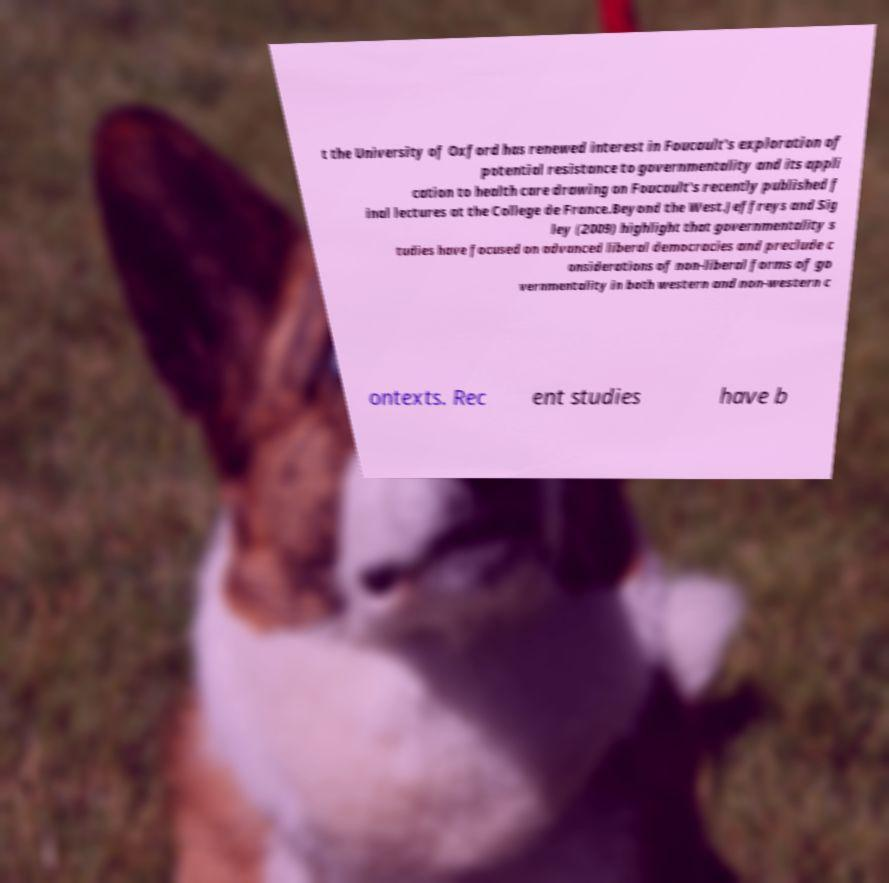Please read and relay the text visible in this image. What does it say? t the University of Oxford has renewed interest in Foucault's exploration of potential resistance to governmentality and its appli cation to health care drawing on Foucault's recently published f inal lectures at the College de France.Beyond the West.Jeffreys and Sig ley (2009) highlight that governmentality s tudies have focused on advanced liberal democracies and preclude c onsiderations of non-liberal forms of go vernmentality in both western and non-western c ontexts. Rec ent studies have b 